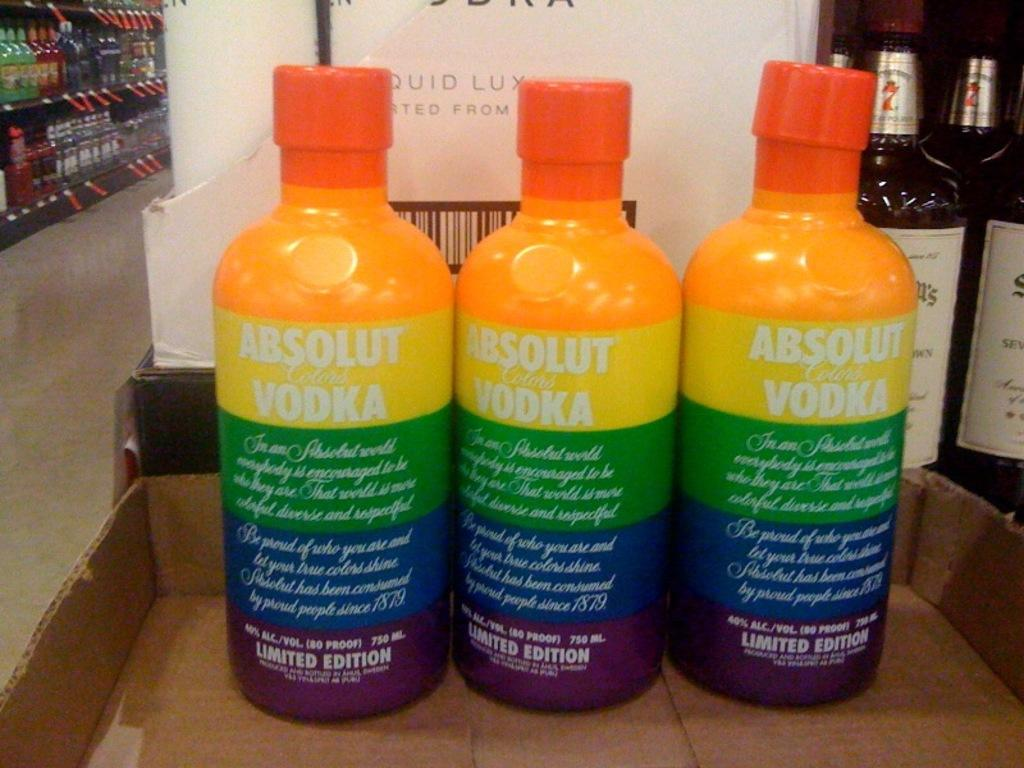How many bottles are in the box in the image? There are three bottles in a box in the image. What is the surface visible in the image? The image shows a floor. Where are the other bottles located besides the box? The other bottles are in a rack. What type of leather is used to make the lace on the machine in the image? There is no leather, lace, or machine present in the image. 